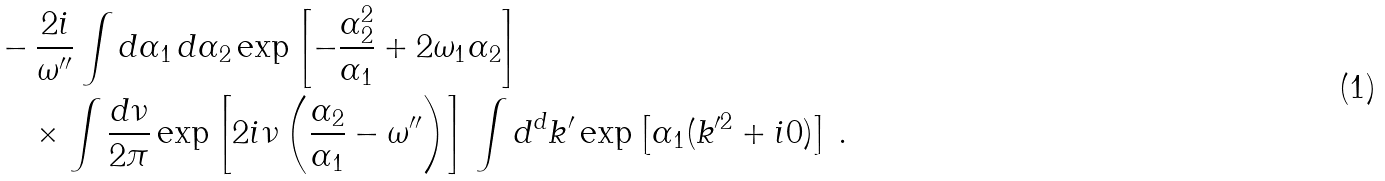<formula> <loc_0><loc_0><loc_500><loc_500>& - \frac { 2 i } { \omega ^ { \prime \prime } } \int d \alpha _ { 1 } \, d \alpha _ { 2 } \exp \left [ - \frac { \alpha _ { 2 } ^ { 2 } } { \alpha _ { 1 } } + 2 \omega _ { 1 } \alpha _ { 2 } \right ] \\ & \quad \times \int \frac { d \nu } { 2 \pi } \exp \left [ 2 i \nu \left ( \frac { \alpha _ { 2 } } { \alpha _ { 1 } } - \omega ^ { \prime \prime } \right ) \right ] \, \int d ^ { d } k ^ { \prime } \exp \left [ \alpha _ { 1 } ( k ^ { \prime 2 } + i 0 ) \right ] \, .</formula> 